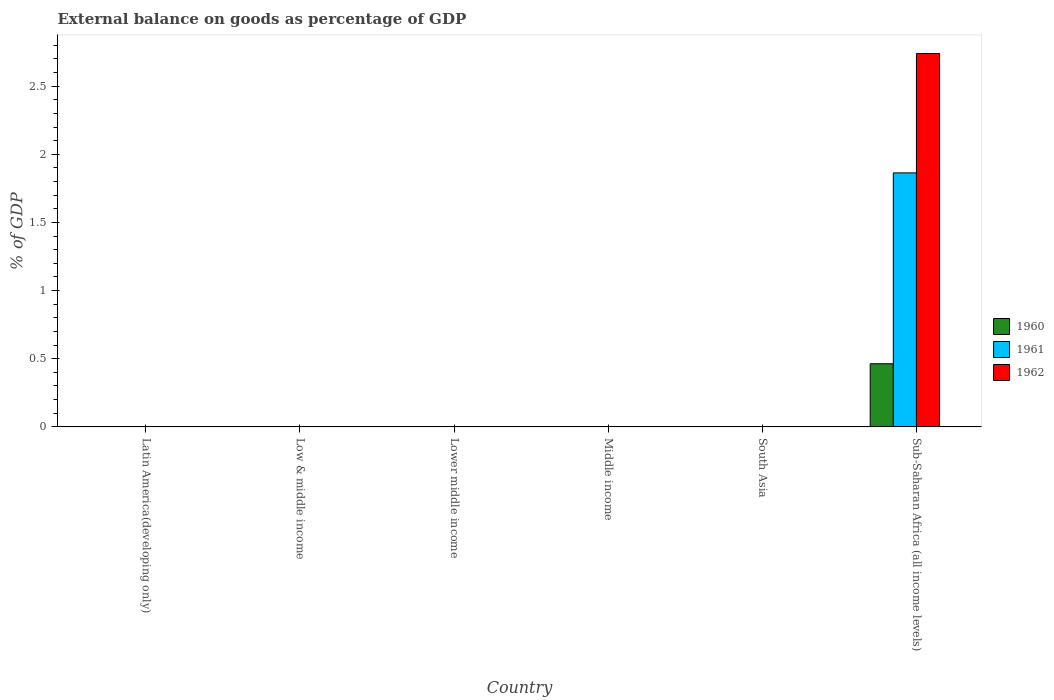How many different coloured bars are there?
Keep it short and to the point. 3. Are the number of bars on each tick of the X-axis equal?
Provide a short and direct response. No. How many bars are there on the 6th tick from the left?
Offer a terse response. 3. What is the label of the 1st group of bars from the left?
Offer a very short reply. Latin America(developing only). Across all countries, what is the maximum external balance on goods as percentage of GDP in 1960?
Offer a terse response. 0.46. In which country was the external balance on goods as percentage of GDP in 1960 maximum?
Your answer should be very brief. Sub-Saharan Africa (all income levels). What is the total external balance on goods as percentage of GDP in 1960 in the graph?
Your answer should be compact. 0.46. What is the difference between the external balance on goods as percentage of GDP in 1962 in Latin America(developing only) and the external balance on goods as percentage of GDP in 1961 in Middle income?
Ensure brevity in your answer.  0. What is the average external balance on goods as percentage of GDP in 1962 per country?
Ensure brevity in your answer.  0.46. What is the difference between the external balance on goods as percentage of GDP of/in 1960 and external balance on goods as percentage of GDP of/in 1962 in Sub-Saharan Africa (all income levels)?
Your response must be concise. -2.28. In how many countries, is the external balance on goods as percentage of GDP in 1960 greater than 1.4 %?
Your answer should be compact. 0. What is the difference between the highest and the lowest external balance on goods as percentage of GDP in 1961?
Provide a succinct answer. 1.86. In how many countries, is the external balance on goods as percentage of GDP in 1962 greater than the average external balance on goods as percentage of GDP in 1962 taken over all countries?
Make the answer very short. 1. Is it the case that in every country, the sum of the external balance on goods as percentage of GDP in 1961 and external balance on goods as percentage of GDP in 1962 is greater than the external balance on goods as percentage of GDP in 1960?
Provide a succinct answer. No. What is the difference between two consecutive major ticks on the Y-axis?
Keep it short and to the point. 0.5. Does the graph contain any zero values?
Provide a succinct answer. Yes. Where does the legend appear in the graph?
Your answer should be very brief. Center right. How are the legend labels stacked?
Provide a short and direct response. Vertical. What is the title of the graph?
Provide a short and direct response. External balance on goods as percentage of GDP. Does "1977" appear as one of the legend labels in the graph?
Your answer should be compact. No. What is the label or title of the X-axis?
Ensure brevity in your answer.  Country. What is the label or title of the Y-axis?
Give a very brief answer. % of GDP. What is the % of GDP in 1960 in Latin America(developing only)?
Offer a very short reply. 0. What is the % of GDP in 1961 in Latin America(developing only)?
Provide a succinct answer. 0. What is the % of GDP in 1961 in Low & middle income?
Ensure brevity in your answer.  0. What is the % of GDP of 1960 in Lower middle income?
Your response must be concise. 0. What is the % of GDP of 1961 in Middle income?
Offer a terse response. 0. What is the % of GDP in 1960 in South Asia?
Offer a terse response. 0. What is the % of GDP of 1961 in South Asia?
Offer a very short reply. 0. What is the % of GDP of 1962 in South Asia?
Give a very brief answer. 0. What is the % of GDP in 1960 in Sub-Saharan Africa (all income levels)?
Offer a very short reply. 0.46. What is the % of GDP of 1961 in Sub-Saharan Africa (all income levels)?
Ensure brevity in your answer.  1.86. What is the % of GDP in 1962 in Sub-Saharan Africa (all income levels)?
Your answer should be very brief. 2.74. Across all countries, what is the maximum % of GDP of 1960?
Provide a succinct answer. 0.46. Across all countries, what is the maximum % of GDP in 1961?
Offer a terse response. 1.86. Across all countries, what is the maximum % of GDP in 1962?
Offer a very short reply. 2.74. What is the total % of GDP in 1960 in the graph?
Provide a short and direct response. 0.46. What is the total % of GDP of 1961 in the graph?
Offer a terse response. 1.86. What is the total % of GDP of 1962 in the graph?
Your response must be concise. 2.74. What is the average % of GDP of 1960 per country?
Offer a very short reply. 0.08. What is the average % of GDP of 1961 per country?
Make the answer very short. 0.31. What is the average % of GDP in 1962 per country?
Your response must be concise. 0.46. What is the difference between the % of GDP in 1960 and % of GDP in 1961 in Sub-Saharan Africa (all income levels)?
Your answer should be compact. -1.4. What is the difference between the % of GDP of 1960 and % of GDP of 1962 in Sub-Saharan Africa (all income levels)?
Your answer should be very brief. -2.28. What is the difference between the % of GDP in 1961 and % of GDP in 1962 in Sub-Saharan Africa (all income levels)?
Provide a short and direct response. -0.88. What is the difference between the highest and the lowest % of GDP of 1960?
Your answer should be compact. 0.46. What is the difference between the highest and the lowest % of GDP of 1961?
Keep it short and to the point. 1.86. What is the difference between the highest and the lowest % of GDP of 1962?
Your response must be concise. 2.74. 